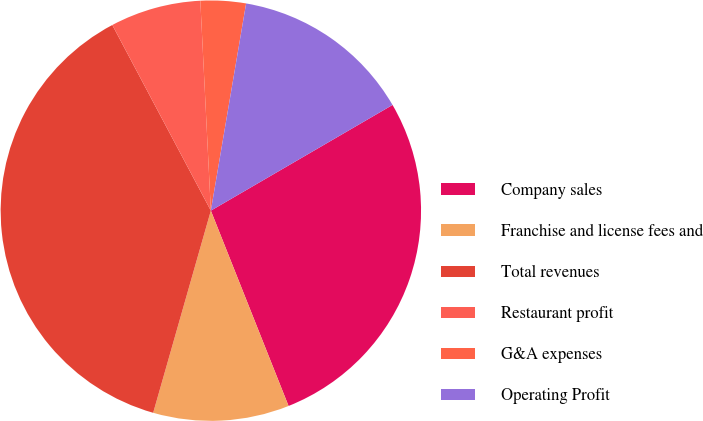<chart> <loc_0><loc_0><loc_500><loc_500><pie_chart><fcel>Company sales<fcel>Franchise and license fees and<fcel>Total revenues<fcel>Restaurant profit<fcel>G&A expenses<fcel>Operating Profit<nl><fcel>27.36%<fcel>10.45%<fcel>37.81%<fcel>6.97%<fcel>3.48%<fcel>13.93%<nl></chart> 